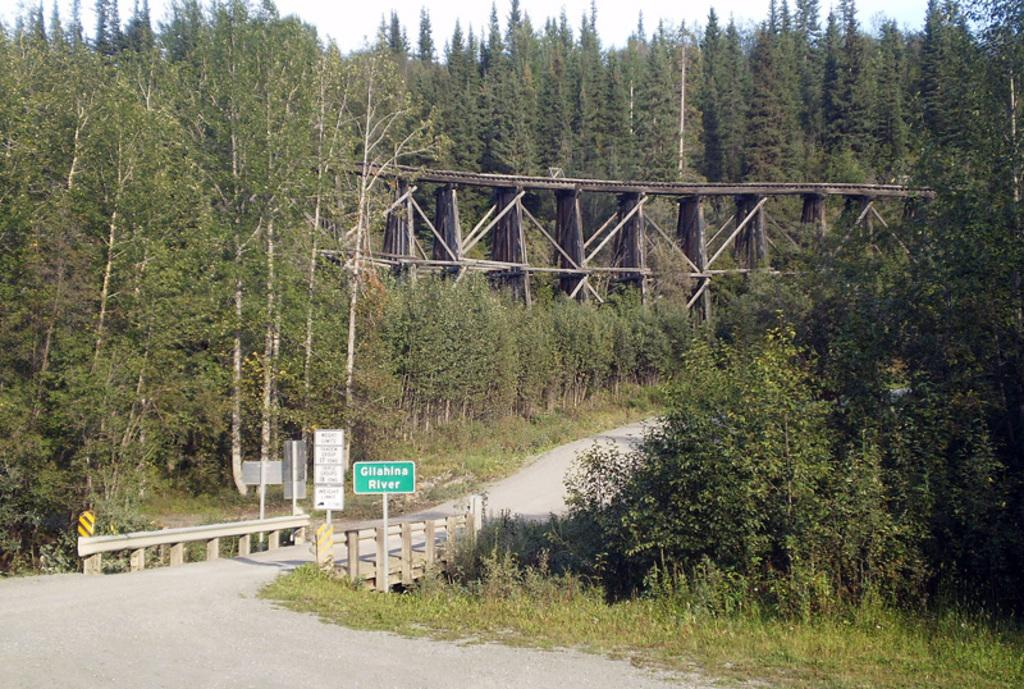What is the main object in the image? There is a green color board in the image. How is the color board positioned in the image? The board is attached to a pole. What can be seen in the background of the image? There are trees and a bridge visible in the background of the image. What is the color of the trees in the image? The trees are green in color. What is the color of the sky in the image? The sky appears to be white in color. How many oranges are hanging from the trees in the image? There are no oranges visible in the image; the trees are green in color. Can you see an eye in the image? There is no eye present in the image. 